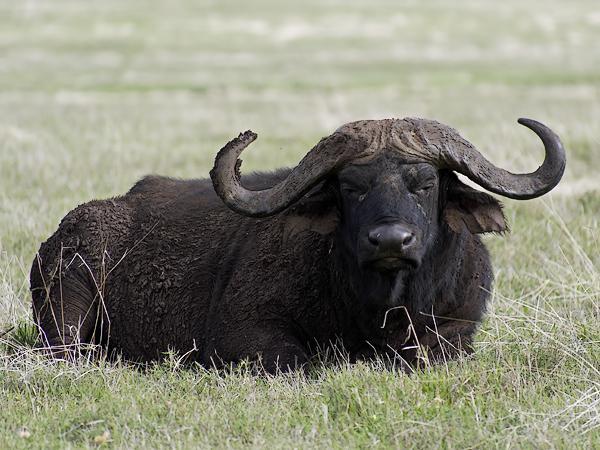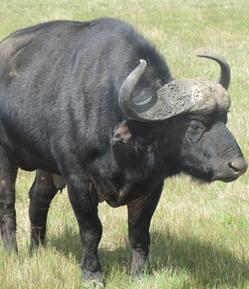The first image is the image on the left, the second image is the image on the right. Given the left and right images, does the statement "The cow in the image on the left is lying down." hold true? Answer yes or no. Yes. The first image is the image on the left, the second image is the image on the right. Considering the images on both sides, is "All water buffalo are standing, and one image contains multiple water buffalo." valid? Answer yes or no. No. 